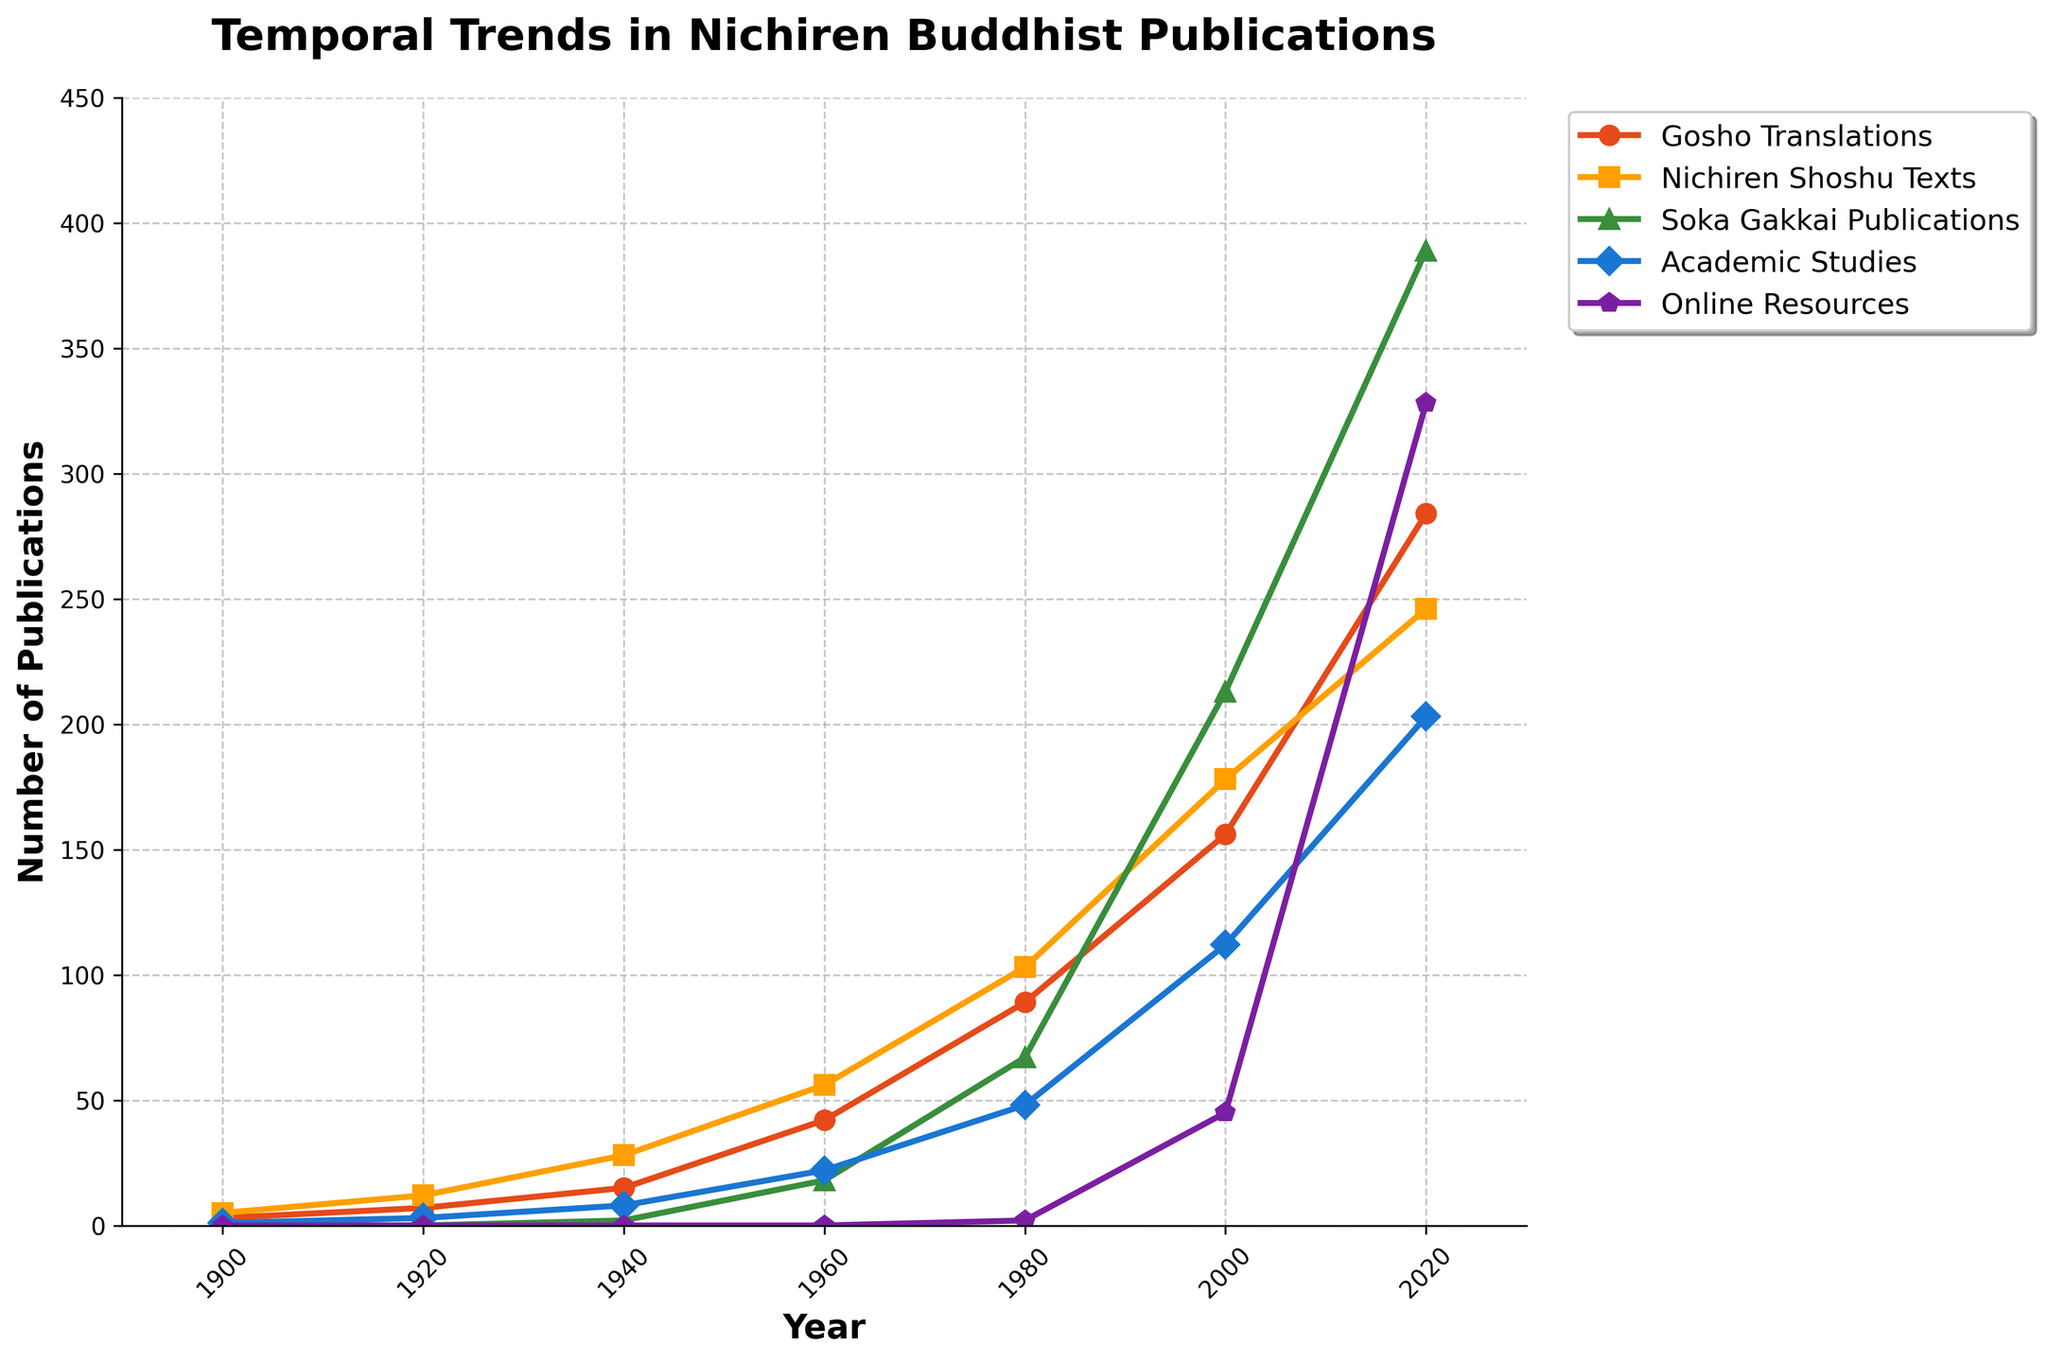What is the total number of publications for "Gosho Translations" and "Soka Gakkai Publications" in the year 2000? First, find the number of publications for each category in the year 2000 from the figure. For "Gosho Translations," it is 156, and for "Soka Gakkai Publications," it is 213. Add these two numbers together: 156 + 213 = 369.
Answer: 369 Which category shows the highest number of publications in 2020? Look at the figure and find the data points for 2020. Compare the heights of the markers for all categories. "Soka Gakkai Publications" has 389 publications, which is the highest.
Answer: Soka Gakkai Publications By how much did the number of publications in "Nichiren Shoshu Texts" increase from 1900 to 1980? Identify the number of publications for "Nichiren Shoshu Texts" in 1900 and 1980 from the figure. In 1900, it is 5, and in 1980, it is 103. Subtract the 1900 value from the 1980 value: 103 - 5 = 98.
Answer: 98 What trend do you observe for "Online Resources" from 1900 to 2020? Examine the plot line for "Online Resources." It starts at 0 from 1900 to 1940, but from 1960 onwards, it shows an increasing trend, reaching 328 in 2020. This indicates that "Online Resources" became significant only after the internet era began.
Answer: Increasing trend starting from 1960 Between which two consecutive periods does "Academic Studies" show the greatest increase in publications? Compare the values for "Academic Studies" across consecutive periods (1900, 1920, 1940, 1960, 1980, 2000, 2020). The largest increase is between 2000 and 2020, from 112 to 203. The difference is 203 - 112 = 91.
Answer: 2000 to 2020 Which category is represented by the green markers, and what is its value in 1960? Locate the green markers in the plot. They represent "Soka Gakkai Publications." Identify the value where the green marker is placed in 1960, which is 18.
Answer: Soka Gakkai Publications, 18 Compare the growth rates of "Gosho Translations" and "Nichiren Shoshu Texts" from 1980 to 2000. Which grew faster? Calculate the increases for both categories. "Gosho Translations" went from 89 to 156 (growth of 67), and "Nichiren Shoshu Texts" went from 103 to 178 (growth of 75). So "Nichiren Shoshu Texts" grew faster.
Answer: Nichiren Shoshu Texts What's the average number of publications for "Academic Studies" across all years? Add the numbers for "Academic Studies" in each year: 1 + 3 + 8 + 22 + 48 + 112 + 203 = 397. Divide by the number of years: 397 / 7 ≈ 56.71.
Answer: 56.71 In which year did "Gosho Translations" surpass 200 publications? Find the data points for "Gosho Translations" across the years and identify the first year where the value exceeds 200. This occurs in 2020 with 284 publications.
Answer: 2020 